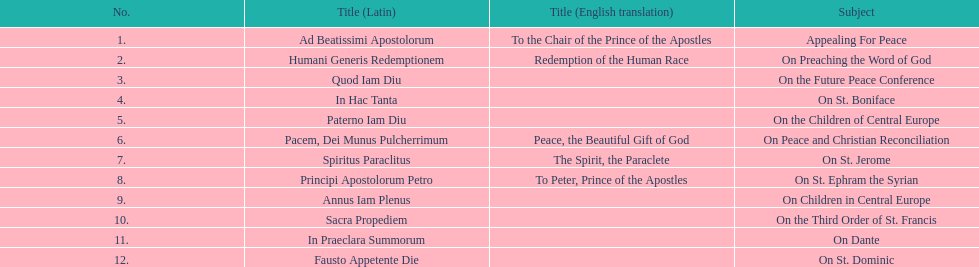Could you help me parse every detail presented in this table? {'header': ['No.', 'Title (Latin)', 'Title (English translation)', 'Subject'], 'rows': [['1.', 'Ad Beatissimi Apostolorum', 'To the Chair of the Prince of the Apostles', 'Appealing For Peace'], ['2.', 'Humani Generis Redemptionem', 'Redemption of the Human Race', 'On Preaching the Word of God'], ['3.', 'Quod Iam Diu', '', 'On the Future Peace Conference'], ['4.', 'In Hac Tanta', '', 'On St. Boniface'], ['5.', 'Paterno Iam Diu', '', 'On the Children of Central Europe'], ['6.', 'Pacem, Dei Munus Pulcherrimum', 'Peace, the Beautiful Gift of God', 'On Peace and Christian Reconciliation'], ['7.', 'Spiritus Paraclitus', 'The Spirit, the Paraclete', 'On St. Jerome'], ['8.', 'Principi Apostolorum Petro', 'To Peter, Prince of the Apostles', 'On St. Ephram the Syrian'], ['9.', 'Annus Iam Plenus', '', 'On Children in Central Europe'], ['10.', 'Sacra Propediem', '', 'On the Third Order of St. Francis'], ['11.', 'In Praeclara Summorum', '', 'On Dante'], ['12.', 'Fausto Appetente Die', '', 'On St. Dominic']]} What is the only subject on 23 may 1920? On Peace and Christian Reconciliation. 